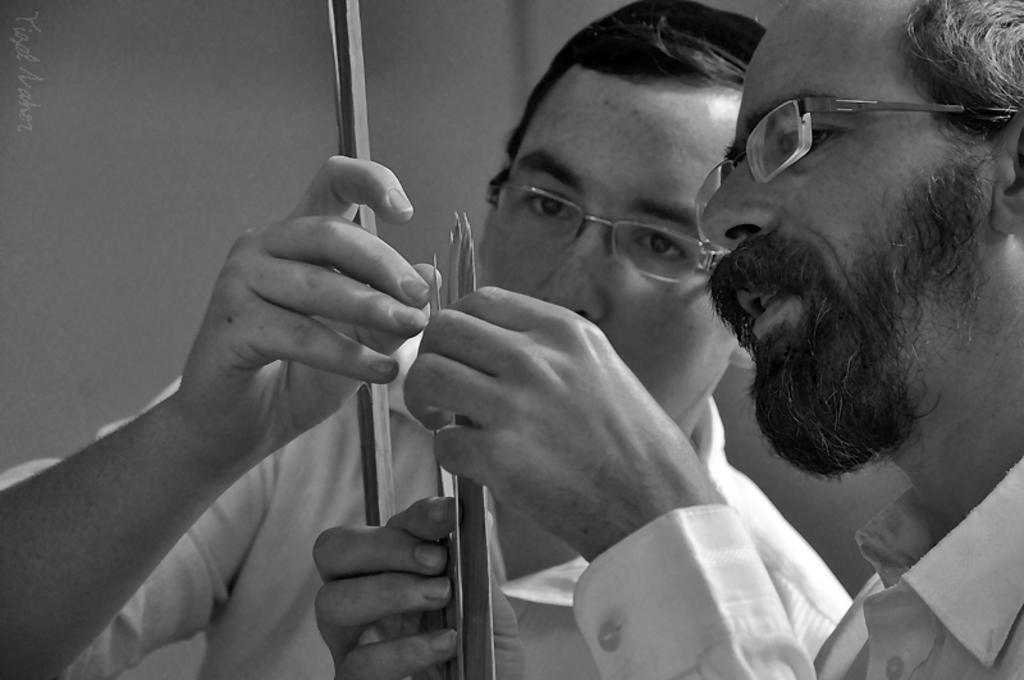Can you describe this image briefly? In this image there are two men, they are wearing spectacles, there are holding an object, there is text towards the left of the image, at the background of the image there is a wall, the background of the image is white in color. 